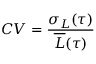<formula> <loc_0><loc_0><loc_500><loc_500>C V = \frac { \sigma _ { L } ( \tau ) } { \overline { L } ( \tau ) }</formula> 